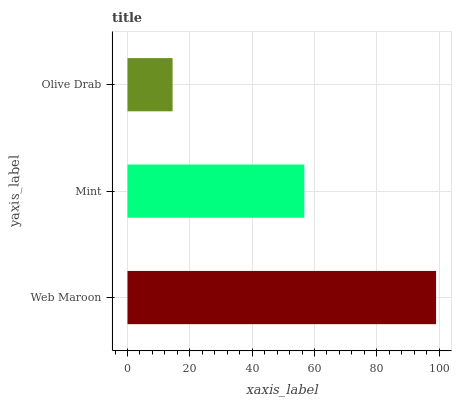Is Olive Drab the minimum?
Answer yes or no. Yes. Is Web Maroon the maximum?
Answer yes or no. Yes. Is Mint the minimum?
Answer yes or no. No. Is Mint the maximum?
Answer yes or no. No. Is Web Maroon greater than Mint?
Answer yes or no. Yes. Is Mint less than Web Maroon?
Answer yes or no. Yes. Is Mint greater than Web Maroon?
Answer yes or no. No. Is Web Maroon less than Mint?
Answer yes or no. No. Is Mint the high median?
Answer yes or no. Yes. Is Mint the low median?
Answer yes or no. Yes. Is Web Maroon the high median?
Answer yes or no. No. Is Olive Drab the low median?
Answer yes or no. No. 